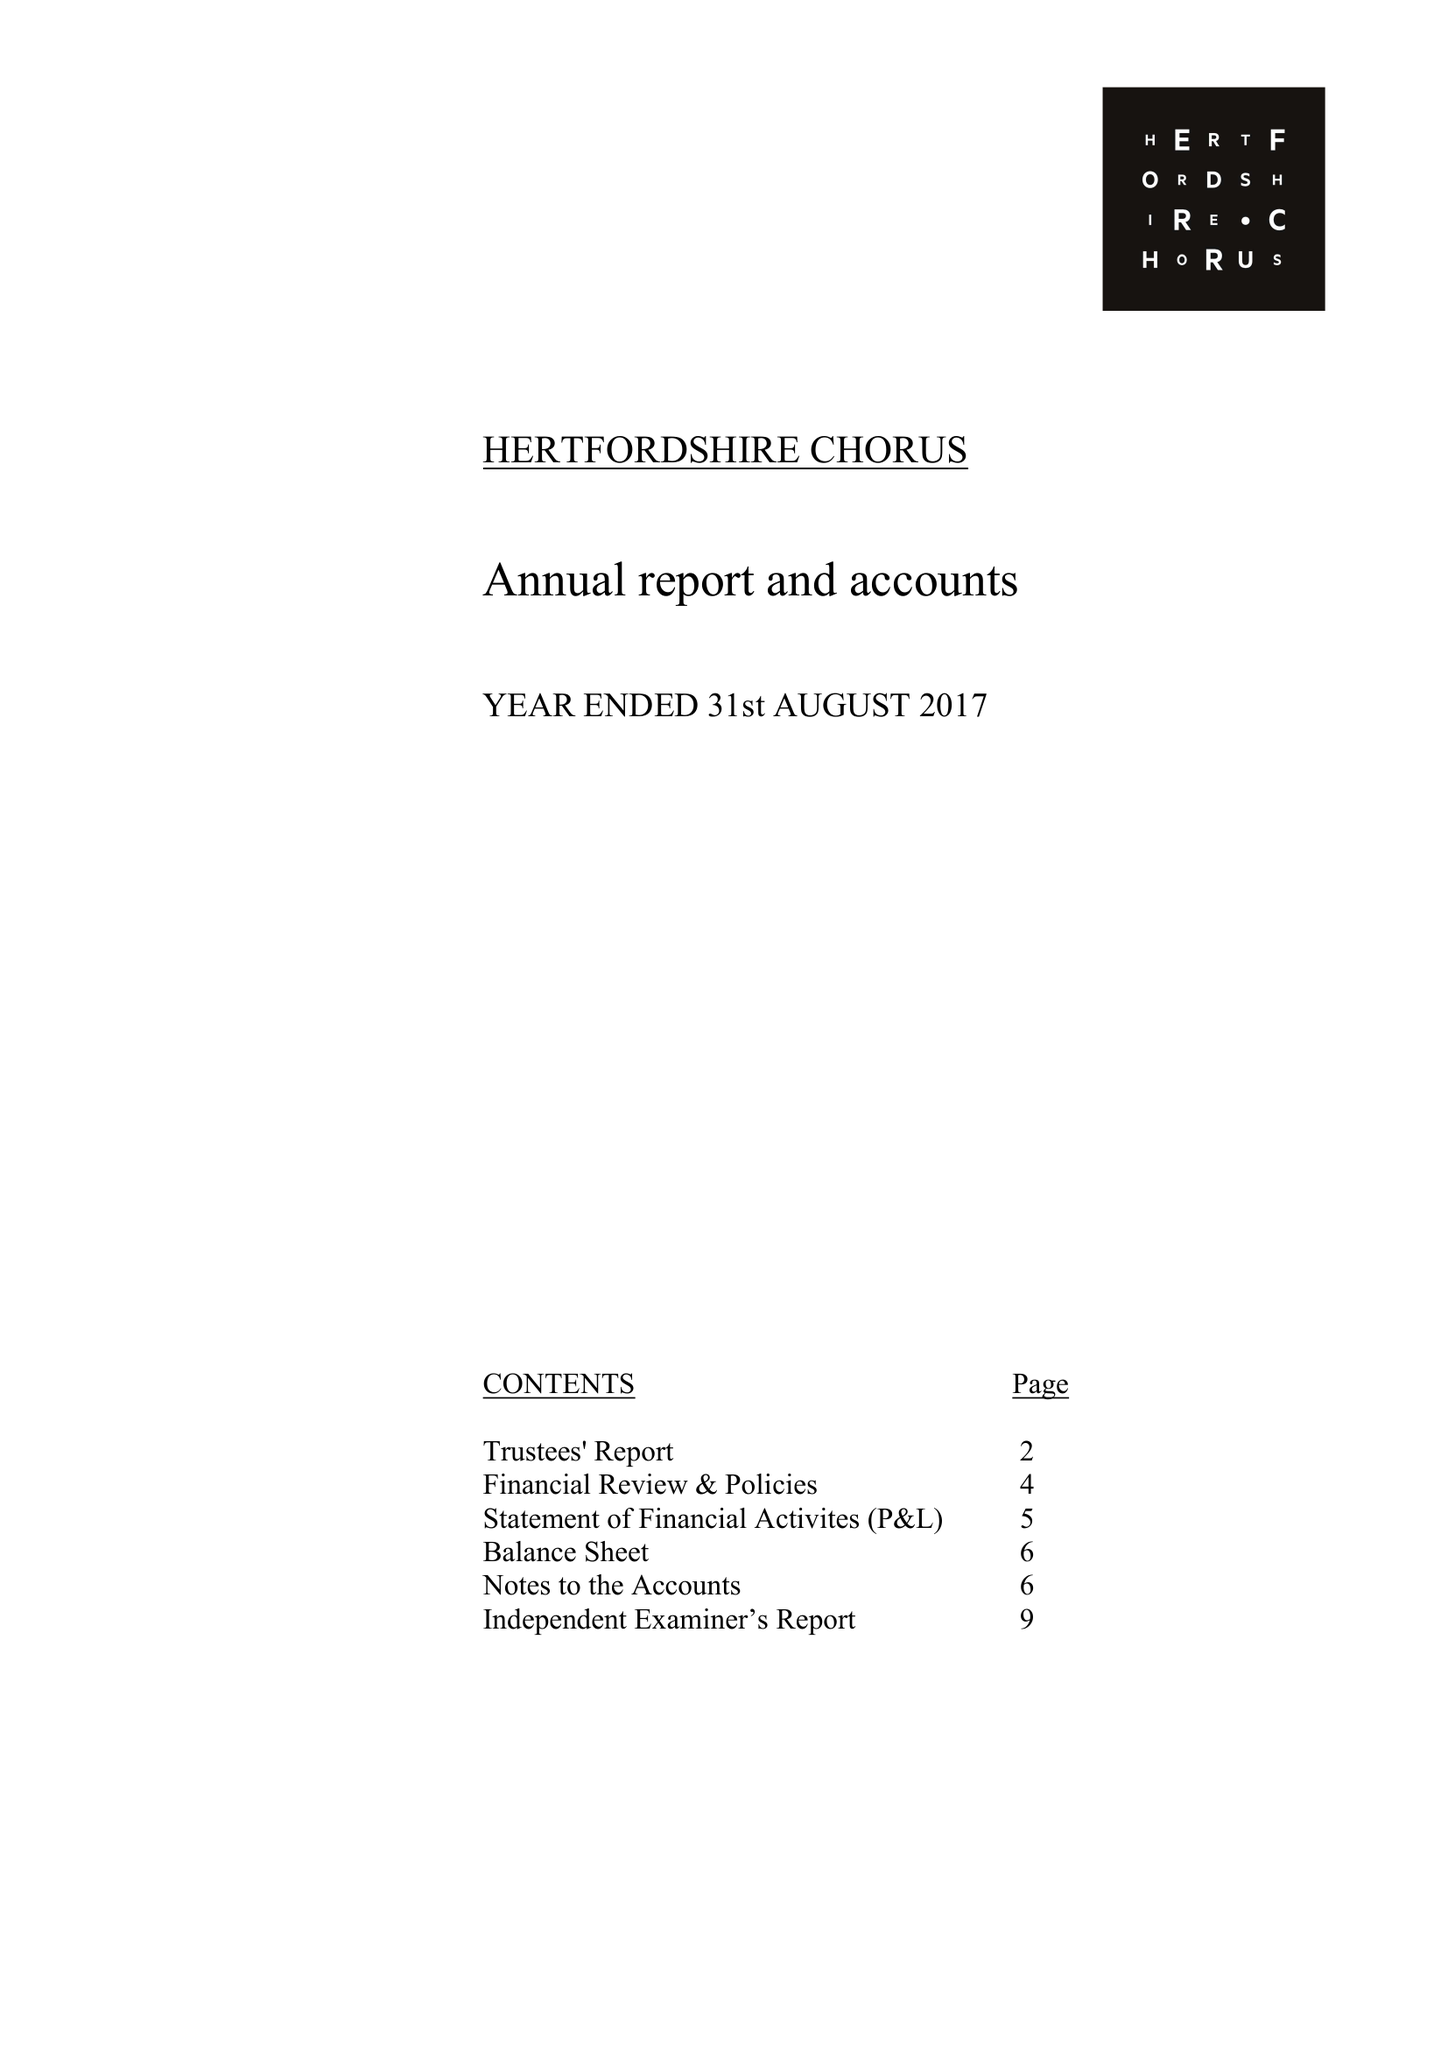What is the value for the charity_name?
Answer the question using a single word or phrase. Hertfordshire Chorus 